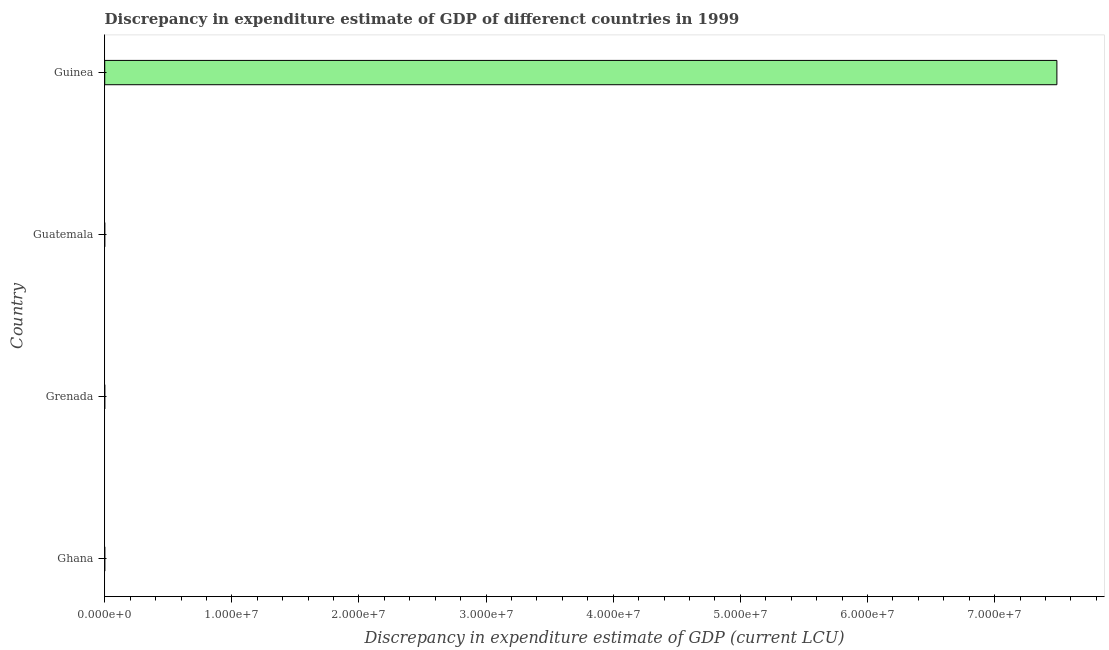Does the graph contain grids?
Offer a very short reply. No. What is the title of the graph?
Make the answer very short. Discrepancy in expenditure estimate of GDP of differenct countries in 1999. What is the label or title of the X-axis?
Offer a terse response. Discrepancy in expenditure estimate of GDP (current LCU). What is the label or title of the Y-axis?
Your answer should be compact. Country. Across all countries, what is the maximum discrepancy in expenditure estimate of gdp?
Offer a terse response. 7.49e+07. In which country was the discrepancy in expenditure estimate of gdp maximum?
Give a very brief answer. Guinea. What is the sum of the discrepancy in expenditure estimate of gdp?
Provide a succinct answer. 7.49e+07. What is the average discrepancy in expenditure estimate of gdp per country?
Your response must be concise. 1.87e+07. What is the median discrepancy in expenditure estimate of gdp?
Provide a succinct answer. 0. What is the difference between the highest and the lowest discrepancy in expenditure estimate of gdp?
Your answer should be very brief. 7.49e+07. How many bars are there?
Give a very brief answer. 1. How many countries are there in the graph?
Provide a short and direct response. 4. What is the difference between two consecutive major ticks on the X-axis?
Keep it short and to the point. 1.00e+07. Are the values on the major ticks of X-axis written in scientific E-notation?
Make the answer very short. Yes. What is the Discrepancy in expenditure estimate of GDP (current LCU) in Guinea?
Make the answer very short. 7.49e+07. 